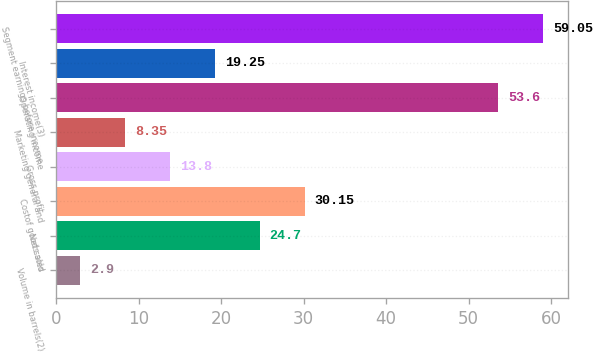Convert chart to OTSL. <chart><loc_0><loc_0><loc_500><loc_500><bar_chart><fcel>Volume in barrels(2)<fcel>Net sales<fcel>Costof goods sold<fcel>Gross profit<fcel>Marketing general and<fcel>Operating income<fcel>Interest income(3)<fcel>Segment earnings before income<nl><fcel>2.9<fcel>24.7<fcel>30.15<fcel>13.8<fcel>8.35<fcel>53.6<fcel>19.25<fcel>59.05<nl></chart> 